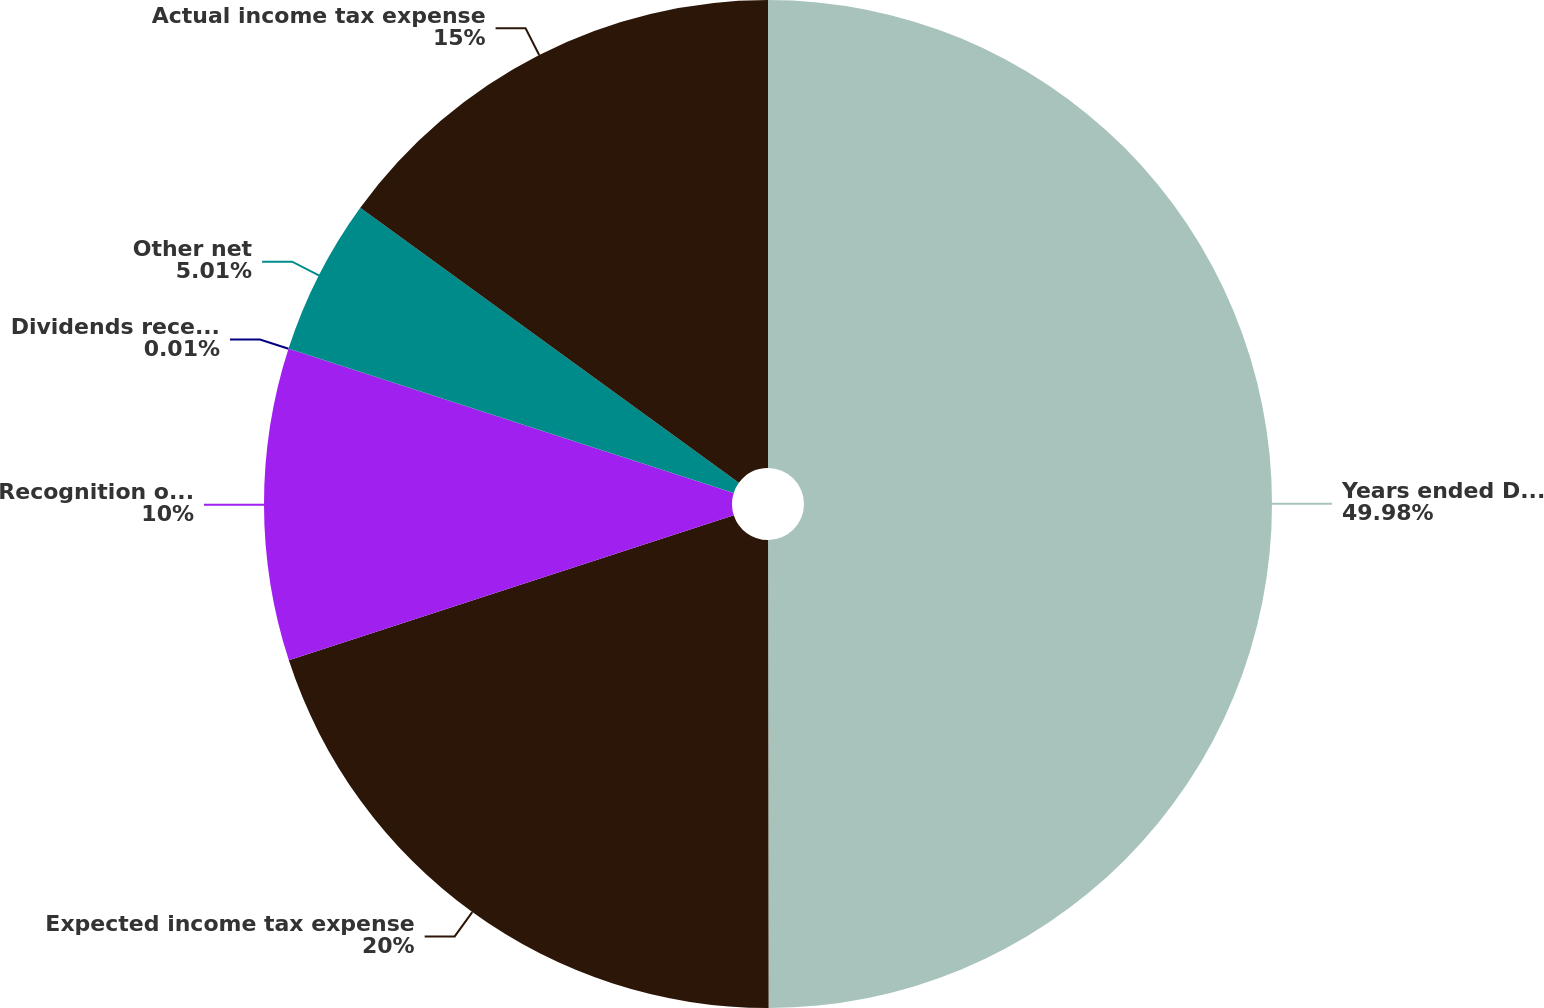Convert chart to OTSL. <chart><loc_0><loc_0><loc_500><loc_500><pie_chart><fcel>Years ended December 31<fcel>Expected income tax expense<fcel>Recognition of income tax<fcel>Dividends received deduction<fcel>Other net<fcel>Actual income tax expense<nl><fcel>49.98%<fcel>20.0%<fcel>10.0%<fcel>0.01%<fcel>5.01%<fcel>15.0%<nl></chart> 